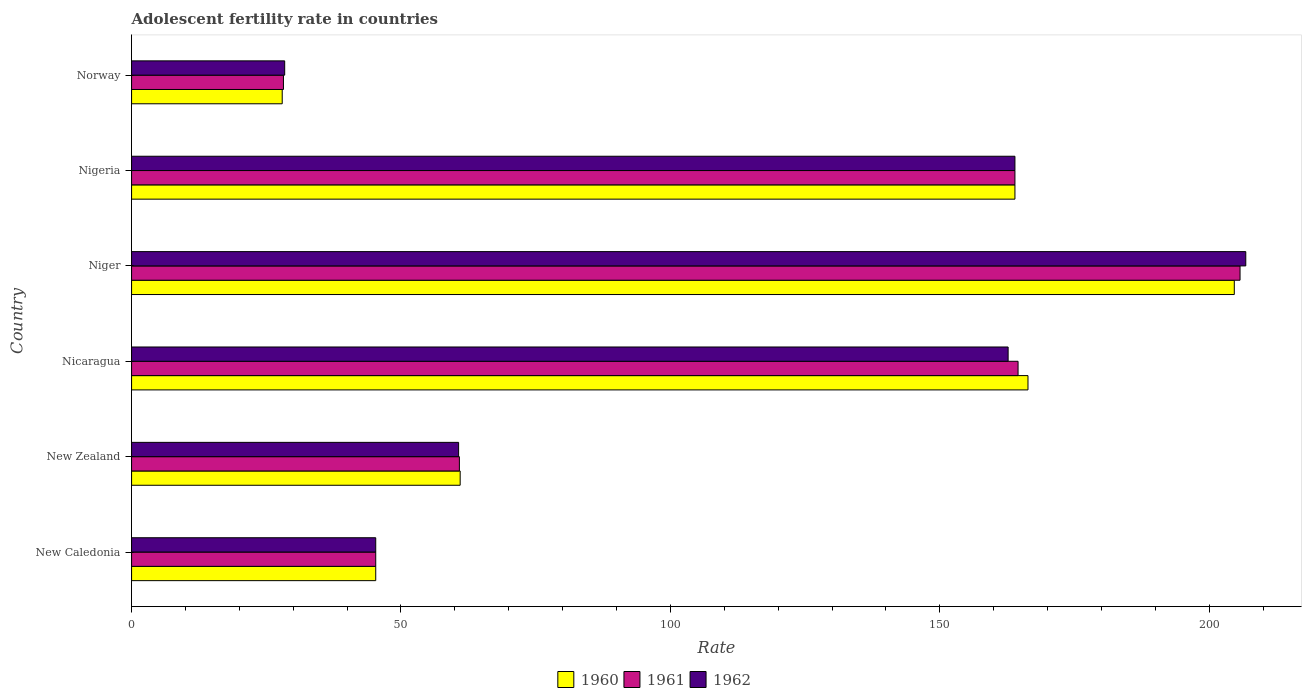How many groups of bars are there?
Ensure brevity in your answer.  6. How many bars are there on the 3rd tick from the top?
Ensure brevity in your answer.  3. What is the label of the 3rd group of bars from the top?
Provide a succinct answer. Niger. In how many cases, is the number of bars for a given country not equal to the number of legend labels?
Provide a succinct answer. 0. What is the adolescent fertility rate in 1961 in New Zealand?
Offer a terse response. 60.84. Across all countries, what is the maximum adolescent fertility rate in 1960?
Offer a terse response. 204.67. Across all countries, what is the minimum adolescent fertility rate in 1961?
Offer a very short reply. 28.19. In which country was the adolescent fertility rate in 1962 maximum?
Offer a terse response. Niger. What is the total adolescent fertility rate in 1961 in the graph?
Your answer should be very brief. 668.57. What is the difference between the adolescent fertility rate in 1960 in New Zealand and that in Nicaragua?
Keep it short and to the point. -105.39. What is the difference between the adolescent fertility rate in 1961 in New Zealand and the adolescent fertility rate in 1962 in Nicaragua?
Keep it short and to the point. -101.85. What is the average adolescent fertility rate in 1961 per country?
Offer a terse response. 111.43. What is the difference between the adolescent fertility rate in 1961 and adolescent fertility rate in 1962 in Niger?
Give a very brief answer. -1.07. What is the ratio of the adolescent fertility rate in 1960 in Niger to that in Norway?
Your response must be concise. 7.32. Is the adolescent fertility rate in 1962 in Nicaragua less than that in Norway?
Your answer should be compact. No. What is the difference between the highest and the second highest adolescent fertility rate in 1961?
Give a very brief answer. 41.2. What is the difference between the highest and the lowest adolescent fertility rate in 1962?
Offer a very short reply. 178.38. What does the 2nd bar from the top in Nigeria represents?
Provide a short and direct response. 1961. What is the difference between two consecutive major ticks on the X-axis?
Provide a short and direct response. 50. Are the values on the major ticks of X-axis written in scientific E-notation?
Keep it short and to the point. No. Does the graph contain any zero values?
Your answer should be compact. No. Where does the legend appear in the graph?
Offer a terse response. Bottom center. How many legend labels are there?
Make the answer very short. 3. What is the title of the graph?
Keep it short and to the point. Adolescent fertility rate in countries. Does "1977" appear as one of the legend labels in the graph?
Ensure brevity in your answer.  No. What is the label or title of the X-axis?
Ensure brevity in your answer.  Rate. What is the Rate of 1960 in New Caledonia?
Make the answer very short. 45.32. What is the Rate of 1961 in New Caledonia?
Make the answer very short. 45.32. What is the Rate of 1962 in New Caledonia?
Your answer should be very brief. 45.32. What is the Rate of 1960 in New Zealand?
Provide a succinct answer. 60.99. What is the Rate of 1961 in New Zealand?
Ensure brevity in your answer.  60.84. What is the Rate in 1962 in New Zealand?
Offer a very short reply. 60.7. What is the Rate in 1960 in Nicaragua?
Provide a short and direct response. 166.38. What is the Rate of 1961 in Nicaragua?
Provide a succinct answer. 164.53. What is the Rate in 1962 in Nicaragua?
Your answer should be compact. 162.69. What is the Rate of 1960 in Niger?
Offer a very short reply. 204.67. What is the Rate of 1961 in Niger?
Keep it short and to the point. 205.74. What is the Rate of 1962 in Niger?
Your response must be concise. 206.8. What is the Rate of 1960 in Nigeria?
Ensure brevity in your answer.  163.96. What is the Rate of 1961 in Nigeria?
Make the answer very short. 163.96. What is the Rate of 1962 in Nigeria?
Your response must be concise. 163.96. What is the Rate of 1960 in Norway?
Make the answer very short. 27.96. What is the Rate of 1961 in Norway?
Give a very brief answer. 28.19. What is the Rate of 1962 in Norway?
Offer a very short reply. 28.42. Across all countries, what is the maximum Rate of 1960?
Make the answer very short. 204.67. Across all countries, what is the maximum Rate of 1961?
Provide a short and direct response. 205.74. Across all countries, what is the maximum Rate in 1962?
Offer a very short reply. 206.8. Across all countries, what is the minimum Rate in 1960?
Offer a very short reply. 27.96. Across all countries, what is the minimum Rate of 1961?
Your response must be concise. 28.19. Across all countries, what is the minimum Rate in 1962?
Keep it short and to the point. 28.42. What is the total Rate in 1960 in the graph?
Your answer should be compact. 669.27. What is the total Rate of 1961 in the graph?
Offer a terse response. 668.57. What is the total Rate of 1962 in the graph?
Give a very brief answer. 667.88. What is the difference between the Rate of 1960 in New Caledonia and that in New Zealand?
Provide a succinct answer. -15.67. What is the difference between the Rate in 1961 in New Caledonia and that in New Zealand?
Provide a succinct answer. -15.53. What is the difference between the Rate of 1962 in New Caledonia and that in New Zealand?
Your answer should be very brief. -15.38. What is the difference between the Rate in 1960 in New Caledonia and that in Nicaragua?
Ensure brevity in your answer.  -121.06. What is the difference between the Rate of 1961 in New Caledonia and that in Nicaragua?
Provide a short and direct response. -119.22. What is the difference between the Rate in 1962 in New Caledonia and that in Nicaragua?
Your answer should be compact. -117.38. What is the difference between the Rate of 1960 in New Caledonia and that in Niger?
Your response must be concise. -159.35. What is the difference between the Rate in 1961 in New Caledonia and that in Niger?
Make the answer very short. -160.42. What is the difference between the Rate of 1962 in New Caledonia and that in Niger?
Your response must be concise. -161.49. What is the difference between the Rate of 1960 in New Caledonia and that in Nigeria?
Offer a terse response. -118.64. What is the difference between the Rate in 1961 in New Caledonia and that in Nigeria?
Keep it short and to the point. -118.64. What is the difference between the Rate in 1962 in New Caledonia and that in Nigeria?
Make the answer very short. -118.64. What is the difference between the Rate in 1960 in New Caledonia and that in Norway?
Offer a very short reply. 17.36. What is the difference between the Rate of 1961 in New Caledonia and that in Norway?
Provide a short and direct response. 17.13. What is the difference between the Rate of 1962 in New Caledonia and that in Norway?
Your response must be concise. 16.9. What is the difference between the Rate in 1960 in New Zealand and that in Nicaragua?
Offer a terse response. -105.39. What is the difference between the Rate in 1961 in New Zealand and that in Nicaragua?
Your answer should be compact. -103.69. What is the difference between the Rate in 1962 in New Zealand and that in Nicaragua?
Your answer should be compact. -101.99. What is the difference between the Rate in 1960 in New Zealand and that in Niger?
Make the answer very short. -143.68. What is the difference between the Rate in 1961 in New Zealand and that in Niger?
Your response must be concise. -144.89. What is the difference between the Rate of 1962 in New Zealand and that in Niger?
Give a very brief answer. -146.1. What is the difference between the Rate of 1960 in New Zealand and that in Nigeria?
Ensure brevity in your answer.  -102.97. What is the difference between the Rate of 1961 in New Zealand and that in Nigeria?
Offer a terse response. -103.11. What is the difference between the Rate of 1962 in New Zealand and that in Nigeria?
Give a very brief answer. -103.26. What is the difference between the Rate of 1960 in New Zealand and that in Norway?
Provide a succinct answer. 33.03. What is the difference between the Rate of 1961 in New Zealand and that in Norway?
Your answer should be compact. 32.66. What is the difference between the Rate in 1962 in New Zealand and that in Norway?
Provide a succinct answer. 32.28. What is the difference between the Rate of 1960 in Nicaragua and that in Niger?
Keep it short and to the point. -38.29. What is the difference between the Rate of 1961 in Nicaragua and that in Niger?
Your answer should be very brief. -41.2. What is the difference between the Rate of 1962 in Nicaragua and that in Niger?
Make the answer very short. -44.11. What is the difference between the Rate of 1960 in Nicaragua and that in Nigeria?
Your answer should be very brief. 2.42. What is the difference between the Rate of 1961 in Nicaragua and that in Nigeria?
Provide a succinct answer. 0.58. What is the difference between the Rate of 1962 in Nicaragua and that in Nigeria?
Your answer should be very brief. -1.26. What is the difference between the Rate of 1960 in Nicaragua and that in Norway?
Offer a terse response. 138.42. What is the difference between the Rate in 1961 in Nicaragua and that in Norway?
Your response must be concise. 136.35. What is the difference between the Rate in 1962 in Nicaragua and that in Norway?
Your response must be concise. 134.27. What is the difference between the Rate of 1960 in Niger and that in Nigeria?
Offer a terse response. 40.71. What is the difference between the Rate of 1961 in Niger and that in Nigeria?
Keep it short and to the point. 41.78. What is the difference between the Rate in 1962 in Niger and that in Nigeria?
Provide a short and direct response. 42.84. What is the difference between the Rate of 1960 in Niger and that in Norway?
Your answer should be compact. 176.71. What is the difference between the Rate of 1961 in Niger and that in Norway?
Your response must be concise. 177.55. What is the difference between the Rate of 1962 in Niger and that in Norway?
Your answer should be very brief. 178.38. What is the difference between the Rate in 1960 in Nigeria and that in Norway?
Give a very brief answer. 136. What is the difference between the Rate of 1961 in Nigeria and that in Norway?
Make the answer very short. 135.77. What is the difference between the Rate in 1962 in Nigeria and that in Norway?
Give a very brief answer. 135.54. What is the difference between the Rate in 1960 in New Caledonia and the Rate in 1961 in New Zealand?
Offer a very short reply. -15.53. What is the difference between the Rate in 1960 in New Caledonia and the Rate in 1962 in New Zealand?
Your answer should be very brief. -15.38. What is the difference between the Rate in 1961 in New Caledonia and the Rate in 1962 in New Zealand?
Ensure brevity in your answer.  -15.38. What is the difference between the Rate in 1960 in New Caledonia and the Rate in 1961 in Nicaragua?
Your answer should be compact. -119.22. What is the difference between the Rate in 1960 in New Caledonia and the Rate in 1962 in Nicaragua?
Keep it short and to the point. -117.38. What is the difference between the Rate of 1961 in New Caledonia and the Rate of 1962 in Nicaragua?
Keep it short and to the point. -117.38. What is the difference between the Rate in 1960 in New Caledonia and the Rate in 1961 in Niger?
Make the answer very short. -160.42. What is the difference between the Rate in 1960 in New Caledonia and the Rate in 1962 in Niger?
Your answer should be very brief. -161.49. What is the difference between the Rate of 1961 in New Caledonia and the Rate of 1962 in Niger?
Give a very brief answer. -161.49. What is the difference between the Rate in 1960 in New Caledonia and the Rate in 1961 in Nigeria?
Ensure brevity in your answer.  -118.64. What is the difference between the Rate of 1960 in New Caledonia and the Rate of 1962 in Nigeria?
Give a very brief answer. -118.64. What is the difference between the Rate of 1961 in New Caledonia and the Rate of 1962 in Nigeria?
Your answer should be very brief. -118.64. What is the difference between the Rate in 1960 in New Caledonia and the Rate in 1961 in Norway?
Make the answer very short. 17.13. What is the difference between the Rate of 1960 in New Caledonia and the Rate of 1962 in Norway?
Keep it short and to the point. 16.9. What is the difference between the Rate of 1961 in New Caledonia and the Rate of 1962 in Norway?
Your answer should be very brief. 16.9. What is the difference between the Rate in 1960 in New Zealand and the Rate in 1961 in Nicaragua?
Your answer should be compact. -103.55. What is the difference between the Rate in 1960 in New Zealand and the Rate in 1962 in Nicaragua?
Keep it short and to the point. -101.7. What is the difference between the Rate in 1961 in New Zealand and the Rate in 1962 in Nicaragua?
Your response must be concise. -101.85. What is the difference between the Rate of 1960 in New Zealand and the Rate of 1961 in Niger?
Ensure brevity in your answer.  -144.75. What is the difference between the Rate in 1960 in New Zealand and the Rate in 1962 in Niger?
Keep it short and to the point. -145.81. What is the difference between the Rate in 1961 in New Zealand and the Rate in 1962 in Niger?
Your response must be concise. -145.96. What is the difference between the Rate in 1960 in New Zealand and the Rate in 1961 in Nigeria?
Offer a terse response. -102.97. What is the difference between the Rate in 1960 in New Zealand and the Rate in 1962 in Nigeria?
Make the answer very short. -102.97. What is the difference between the Rate of 1961 in New Zealand and the Rate of 1962 in Nigeria?
Your answer should be compact. -103.11. What is the difference between the Rate of 1960 in New Zealand and the Rate of 1961 in Norway?
Your response must be concise. 32.8. What is the difference between the Rate of 1960 in New Zealand and the Rate of 1962 in Norway?
Provide a succinct answer. 32.57. What is the difference between the Rate of 1961 in New Zealand and the Rate of 1962 in Norway?
Your answer should be compact. 32.43. What is the difference between the Rate in 1960 in Nicaragua and the Rate in 1961 in Niger?
Ensure brevity in your answer.  -39.36. What is the difference between the Rate of 1960 in Nicaragua and the Rate of 1962 in Niger?
Offer a terse response. -40.42. What is the difference between the Rate of 1961 in Nicaragua and the Rate of 1962 in Niger?
Make the answer very short. -42.27. What is the difference between the Rate in 1960 in Nicaragua and the Rate in 1961 in Nigeria?
Ensure brevity in your answer.  2.42. What is the difference between the Rate of 1960 in Nicaragua and the Rate of 1962 in Nigeria?
Offer a terse response. 2.42. What is the difference between the Rate in 1961 in Nicaragua and the Rate in 1962 in Nigeria?
Your answer should be very brief. 0.58. What is the difference between the Rate in 1960 in Nicaragua and the Rate in 1961 in Norway?
Provide a succinct answer. 138.19. What is the difference between the Rate in 1960 in Nicaragua and the Rate in 1962 in Norway?
Ensure brevity in your answer.  137.96. What is the difference between the Rate in 1961 in Nicaragua and the Rate in 1962 in Norway?
Give a very brief answer. 136.12. What is the difference between the Rate in 1960 in Niger and the Rate in 1961 in Nigeria?
Keep it short and to the point. 40.71. What is the difference between the Rate of 1960 in Niger and the Rate of 1962 in Nigeria?
Your answer should be compact. 40.71. What is the difference between the Rate of 1961 in Niger and the Rate of 1962 in Nigeria?
Provide a short and direct response. 41.78. What is the difference between the Rate of 1960 in Niger and the Rate of 1961 in Norway?
Keep it short and to the point. 176.48. What is the difference between the Rate of 1960 in Niger and the Rate of 1962 in Norway?
Ensure brevity in your answer.  176.25. What is the difference between the Rate of 1961 in Niger and the Rate of 1962 in Norway?
Offer a very short reply. 177.32. What is the difference between the Rate of 1960 in Nigeria and the Rate of 1961 in Norway?
Make the answer very short. 135.77. What is the difference between the Rate of 1960 in Nigeria and the Rate of 1962 in Norway?
Give a very brief answer. 135.54. What is the difference between the Rate of 1961 in Nigeria and the Rate of 1962 in Norway?
Your answer should be compact. 135.54. What is the average Rate in 1960 per country?
Provide a short and direct response. 111.54. What is the average Rate in 1961 per country?
Give a very brief answer. 111.43. What is the average Rate in 1962 per country?
Offer a terse response. 111.31. What is the difference between the Rate in 1960 and Rate in 1961 in New Caledonia?
Your response must be concise. 0. What is the difference between the Rate of 1960 and Rate of 1962 in New Caledonia?
Your response must be concise. 0. What is the difference between the Rate of 1960 and Rate of 1961 in New Zealand?
Offer a terse response. 0.14. What is the difference between the Rate in 1960 and Rate in 1962 in New Zealand?
Keep it short and to the point. 0.29. What is the difference between the Rate in 1961 and Rate in 1962 in New Zealand?
Offer a very short reply. 0.14. What is the difference between the Rate in 1960 and Rate in 1961 in Nicaragua?
Your answer should be compact. 1.84. What is the difference between the Rate in 1960 and Rate in 1962 in Nicaragua?
Give a very brief answer. 3.69. What is the difference between the Rate of 1961 and Rate of 1962 in Nicaragua?
Your answer should be very brief. 1.84. What is the difference between the Rate of 1960 and Rate of 1961 in Niger?
Offer a terse response. -1.07. What is the difference between the Rate of 1960 and Rate of 1962 in Niger?
Make the answer very short. -2.13. What is the difference between the Rate of 1961 and Rate of 1962 in Niger?
Ensure brevity in your answer.  -1.07. What is the difference between the Rate of 1960 and Rate of 1961 in Norway?
Provide a succinct answer. -0.23. What is the difference between the Rate of 1960 and Rate of 1962 in Norway?
Your response must be concise. -0.46. What is the difference between the Rate of 1961 and Rate of 1962 in Norway?
Your response must be concise. -0.23. What is the ratio of the Rate in 1960 in New Caledonia to that in New Zealand?
Ensure brevity in your answer.  0.74. What is the ratio of the Rate in 1961 in New Caledonia to that in New Zealand?
Give a very brief answer. 0.74. What is the ratio of the Rate of 1962 in New Caledonia to that in New Zealand?
Provide a short and direct response. 0.75. What is the ratio of the Rate of 1960 in New Caledonia to that in Nicaragua?
Your answer should be very brief. 0.27. What is the ratio of the Rate in 1961 in New Caledonia to that in Nicaragua?
Your answer should be compact. 0.28. What is the ratio of the Rate of 1962 in New Caledonia to that in Nicaragua?
Ensure brevity in your answer.  0.28. What is the ratio of the Rate in 1960 in New Caledonia to that in Niger?
Ensure brevity in your answer.  0.22. What is the ratio of the Rate of 1961 in New Caledonia to that in Niger?
Your answer should be very brief. 0.22. What is the ratio of the Rate in 1962 in New Caledonia to that in Niger?
Make the answer very short. 0.22. What is the ratio of the Rate in 1960 in New Caledonia to that in Nigeria?
Keep it short and to the point. 0.28. What is the ratio of the Rate of 1961 in New Caledonia to that in Nigeria?
Give a very brief answer. 0.28. What is the ratio of the Rate in 1962 in New Caledonia to that in Nigeria?
Ensure brevity in your answer.  0.28. What is the ratio of the Rate of 1960 in New Caledonia to that in Norway?
Your response must be concise. 1.62. What is the ratio of the Rate of 1961 in New Caledonia to that in Norway?
Your answer should be very brief. 1.61. What is the ratio of the Rate of 1962 in New Caledonia to that in Norway?
Offer a very short reply. 1.59. What is the ratio of the Rate in 1960 in New Zealand to that in Nicaragua?
Offer a terse response. 0.37. What is the ratio of the Rate in 1961 in New Zealand to that in Nicaragua?
Your answer should be very brief. 0.37. What is the ratio of the Rate of 1962 in New Zealand to that in Nicaragua?
Your answer should be compact. 0.37. What is the ratio of the Rate in 1960 in New Zealand to that in Niger?
Your answer should be compact. 0.3. What is the ratio of the Rate in 1961 in New Zealand to that in Niger?
Give a very brief answer. 0.3. What is the ratio of the Rate in 1962 in New Zealand to that in Niger?
Provide a short and direct response. 0.29. What is the ratio of the Rate in 1960 in New Zealand to that in Nigeria?
Provide a short and direct response. 0.37. What is the ratio of the Rate of 1961 in New Zealand to that in Nigeria?
Provide a succinct answer. 0.37. What is the ratio of the Rate in 1962 in New Zealand to that in Nigeria?
Give a very brief answer. 0.37. What is the ratio of the Rate in 1960 in New Zealand to that in Norway?
Your answer should be compact. 2.18. What is the ratio of the Rate in 1961 in New Zealand to that in Norway?
Keep it short and to the point. 2.16. What is the ratio of the Rate of 1962 in New Zealand to that in Norway?
Your answer should be very brief. 2.14. What is the ratio of the Rate in 1960 in Nicaragua to that in Niger?
Your answer should be very brief. 0.81. What is the ratio of the Rate in 1961 in Nicaragua to that in Niger?
Your response must be concise. 0.8. What is the ratio of the Rate in 1962 in Nicaragua to that in Niger?
Keep it short and to the point. 0.79. What is the ratio of the Rate of 1960 in Nicaragua to that in Nigeria?
Provide a succinct answer. 1.01. What is the ratio of the Rate of 1960 in Nicaragua to that in Norway?
Make the answer very short. 5.95. What is the ratio of the Rate of 1961 in Nicaragua to that in Norway?
Offer a terse response. 5.84. What is the ratio of the Rate of 1962 in Nicaragua to that in Norway?
Provide a short and direct response. 5.72. What is the ratio of the Rate in 1960 in Niger to that in Nigeria?
Your answer should be compact. 1.25. What is the ratio of the Rate of 1961 in Niger to that in Nigeria?
Offer a very short reply. 1.25. What is the ratio of the Rate of 1962 in Niger to that in Nigeria?
Make the answer very short. 1.26. What is the ratio of the Rate in 1960 in Niger to that in Norway?
Give a very brief answer. 7.32. What is the ratio of the Rate in 1961 in Niger to that in Norway?
Your answer should be very brief. 7.3. What is the ratio of the Rate of 1962 in Niger to that in Norway?
Your answer should be compact. 7.28. What is the ratio of the Rate in 1960 in Nigeria to that in Norway?
Your response must be concise. 5.86. What is the ratio of the Rate of 1961 in Nigeria to that in Norway?
Keep it short and to the point. 5.82. What is the ratio of the Rate of 1962 in Nigeria to that in Norway?
Provide a short and direct response. 5.77. What is the difference between the highest and the second highest Rate of 1960?
Give a very brief answer. 38.29. What is the difference between the highest and the second highest Rate of 1961?
Make the answer very short. 41.2. What is the difference between the highest and the second highest Rate of 1962?
Ensure brevity in your answer.  42.84. What is the difference between the highest and the lowest Rate in 1960?
Keep it short and to the point. 176.71. What is the difference between the highest and the lowest Rate of 1961?
Provide a succinct answer. 177.55. What is the difference between the highest and the lowest Rate of 1962?
Your response must be concise. 178.38. 